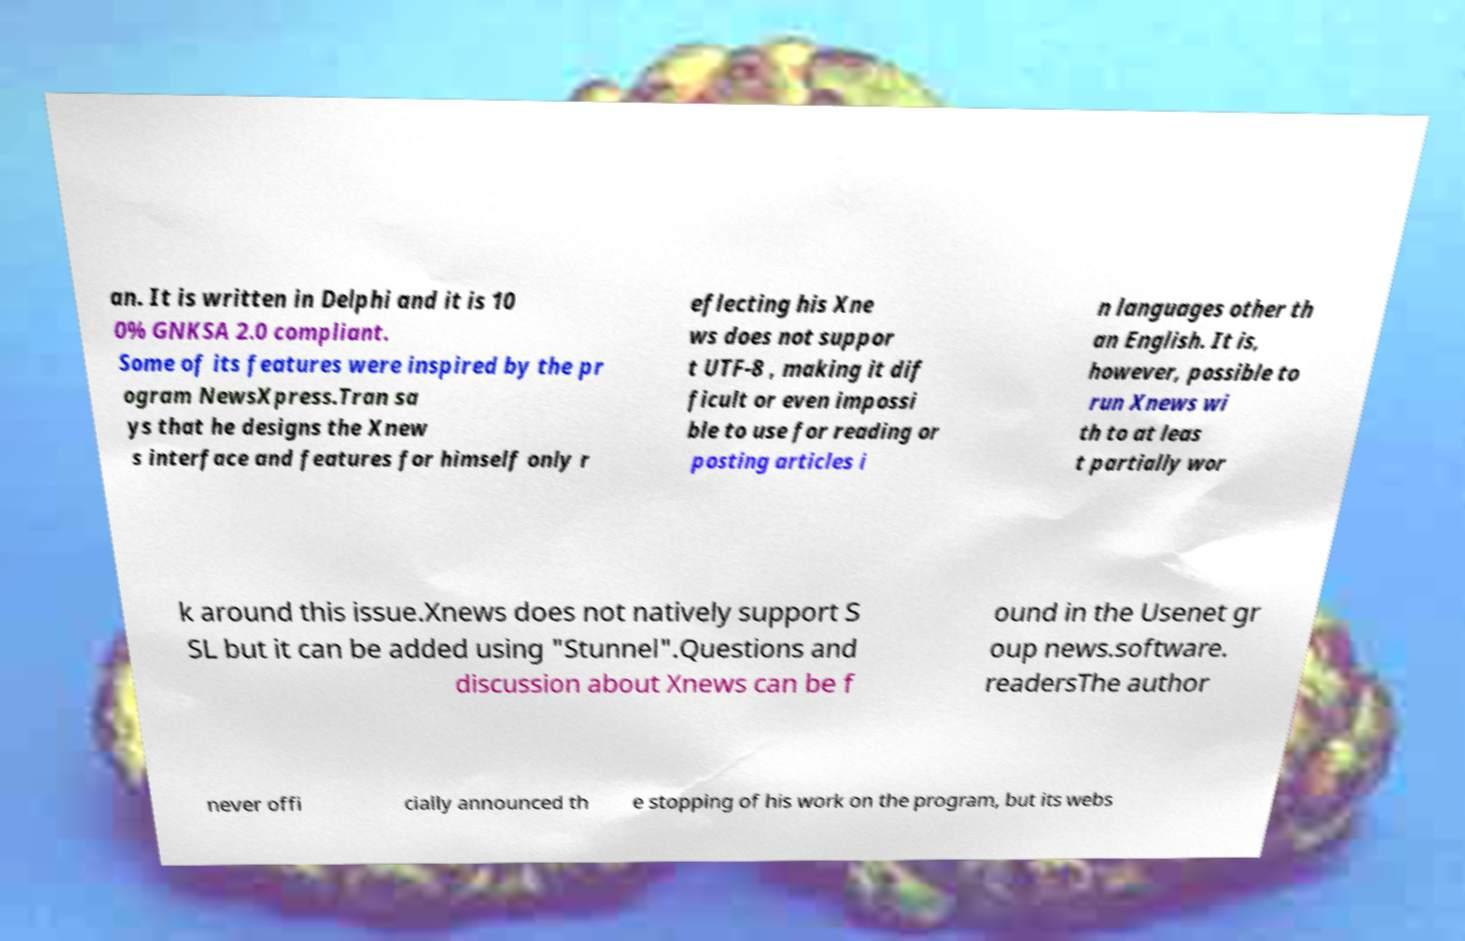There's text embedded in this image that I need extracted. Can you transcribe it verbatim? an. It is written in Delphi and it is 10 0% GNKSA 2.0 compliant. Some of its features were inspired by the pr ogram NewsXpress.Tran sa ys that he designs the Xnew s interface and features for himself only r eflecting his Xne ws does not suppor t UTF-8 , making it dif ficult or even impossi ble to use for reading or posting articles i n languages other th an English. It is, however, possible to run Xnews wi th to at leas t partially wor k around this issue.Xnews does not natively support S SL but it can be added using "Stunnel".Questions and discussion about Xnews can be f ound in the Usenet gr oup news.software. readersThe author never offi cially announced th e stopping of his work on the program, but its webs 